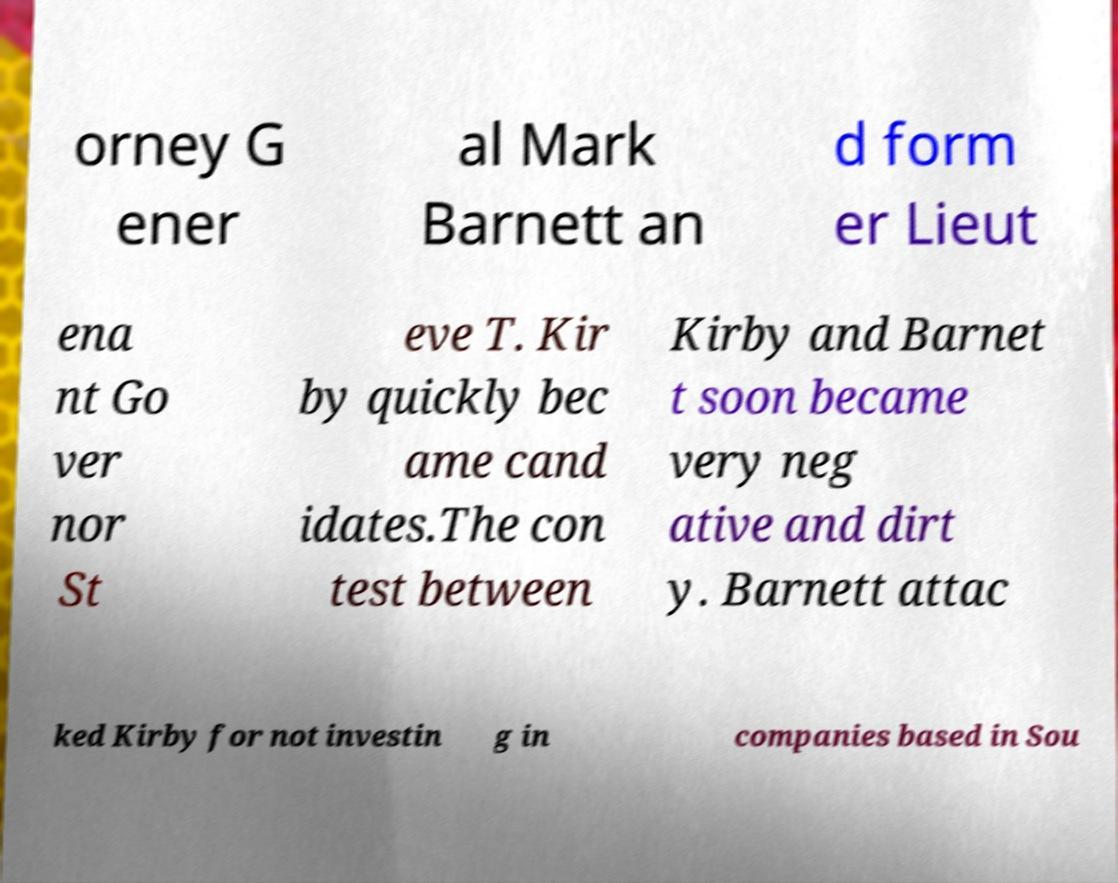Can you read and provide the text displayed in the image?This photo seems to have some interesting text. Can you extract and type it out for me? orney G ener al Mark Barnett an d form er Lieut ena nt Go ver nor St eve T. Kir by quickly bec ame cand idates.The con test between Kirby and Barnet t soon became very neg ative and dirt y. Barnett attac ked Kirby for not investin g in companies based in Sou 